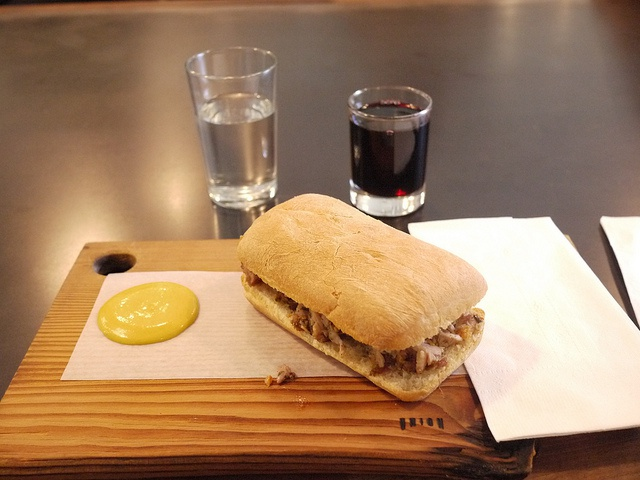Describe the objects in this image and their specific colors. I can see dining table in gray, ivory, tan, and red tones, sandwich in black, tan, brown, and maroon tones, cup in black, gray, tan, and darkgray tones, and cup in black, gray, maroon, and lightgray tones in this image. 